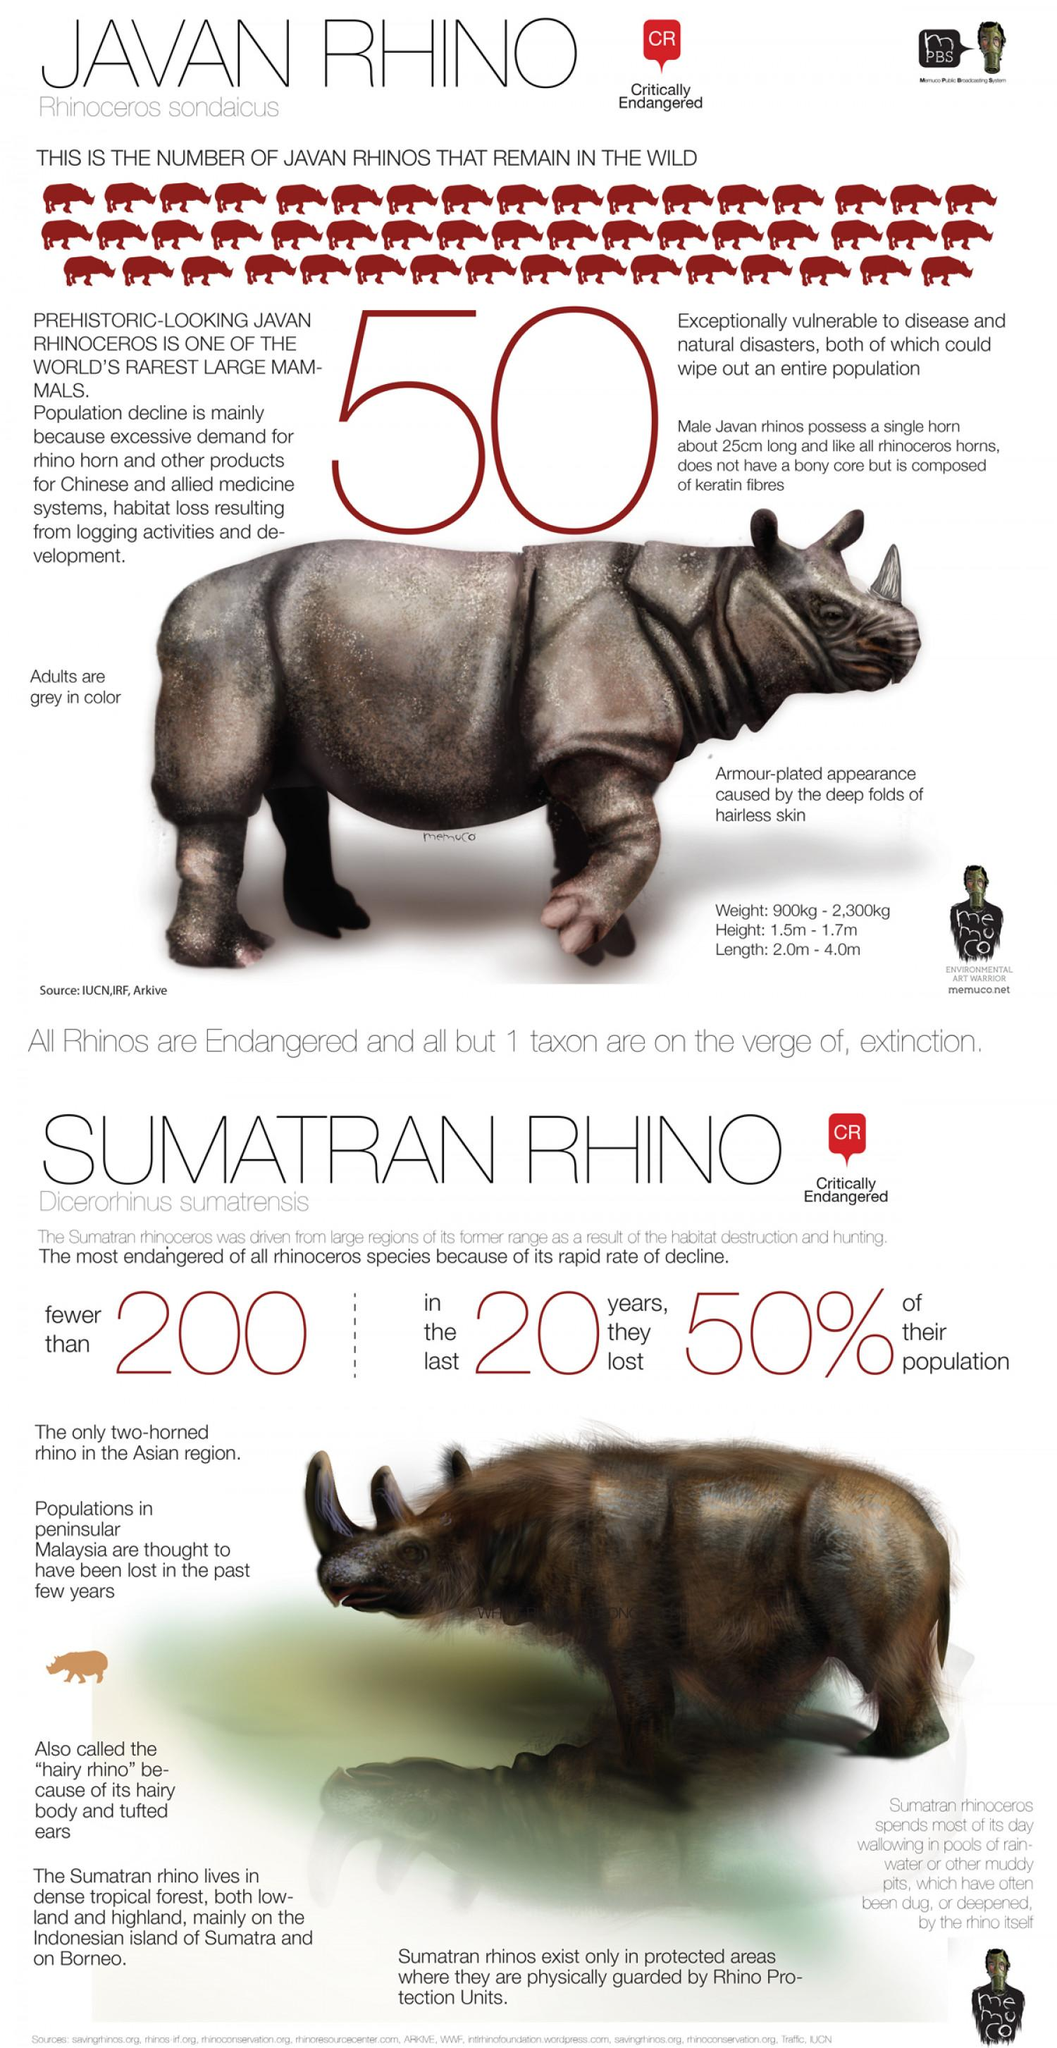Indicate a few pertinent items in this graphic. The minimum height and length of Javan Rhinos is 3.5 meters. The total maximum height and length of Javan Rhinos is 5.7 meters. 